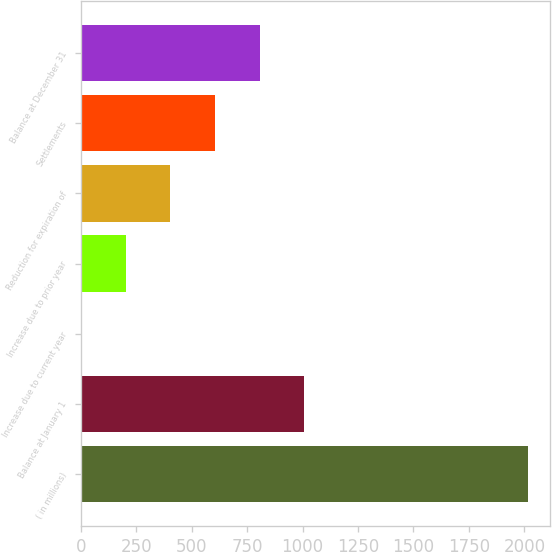Convert chart to OTSL. <chart><loc_0><loc_0><loc_500><loc_500><bar_chart><fcel>( in millions)<fcel>Balance at January 1<fcel>Increase due to current year<fcel>Increase due to prior year<fcel>Reduction for expiration of<fcel>Settlements<fcel>Balance at December 31<nl><fcel>2015<fcel>1007.9<fcel>0.8<fcel>202.22<fcel>403.64<fcel>605.06<fcel>806.48<nl></chart> 